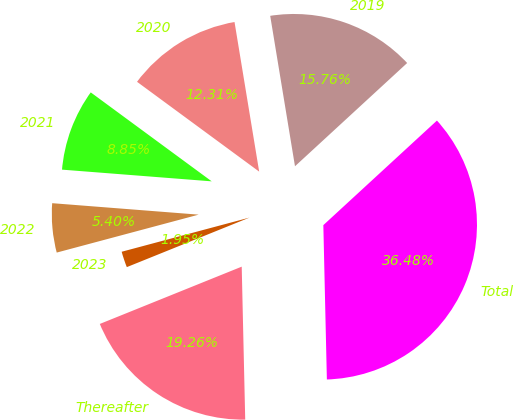Convert chart to OTSL. <chart><loc_0><loc_0><loc_500><loc_500><pie_chart><fcel>2019<fcel>2020<fcel>2021<fcel>2022<fcel>2023<fcel>Thereafter<fcel>Total<nl><fcel>15.76%<fcel>12.31%<fcel>8.85%<fcel>5.4%<fcel>1.95%<fcel>19.26%<fcel>36.48%<nl></chart> 